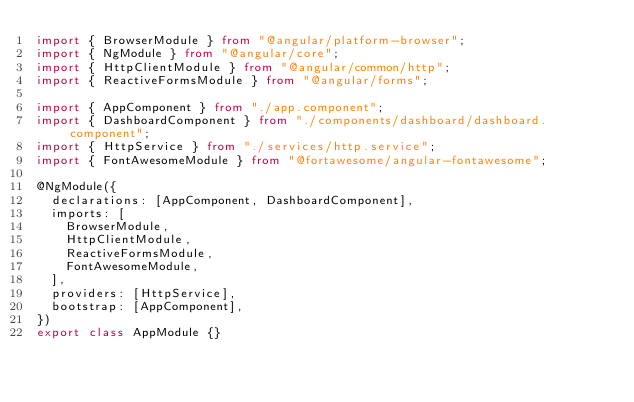Convert code to text. <code><loc_0><loc_0><loc_500><loc_500><_TypeScript_>import { BrowserModule } from "@angular/platform-browser";
import { NgModule } from "@angular/core";
import { HttpClientModule } from "@angular/common/http";
import { ReactiveFormsModule } from "@angular/forms";

import { AppComponent } from "./app.component";
import { DashboardComponent } from "./components/dashboard/dashboard.component";
import { HttpService } from "./services/http.service";
import { FontAwesomeModule } from "@fortawesome/angular-fontawesome";

@NgModule({
  declarations: [AppComponent, DashboardComponent],
  imports: [
    BrowserModule,
    HttpClientModule,
    ReactiveFormsModule,
    FontAwesomeModule,
  ],
  providers: [HttpService],
  bootstrap: [AppComponent],
})
export class AppModule {}
</code> 